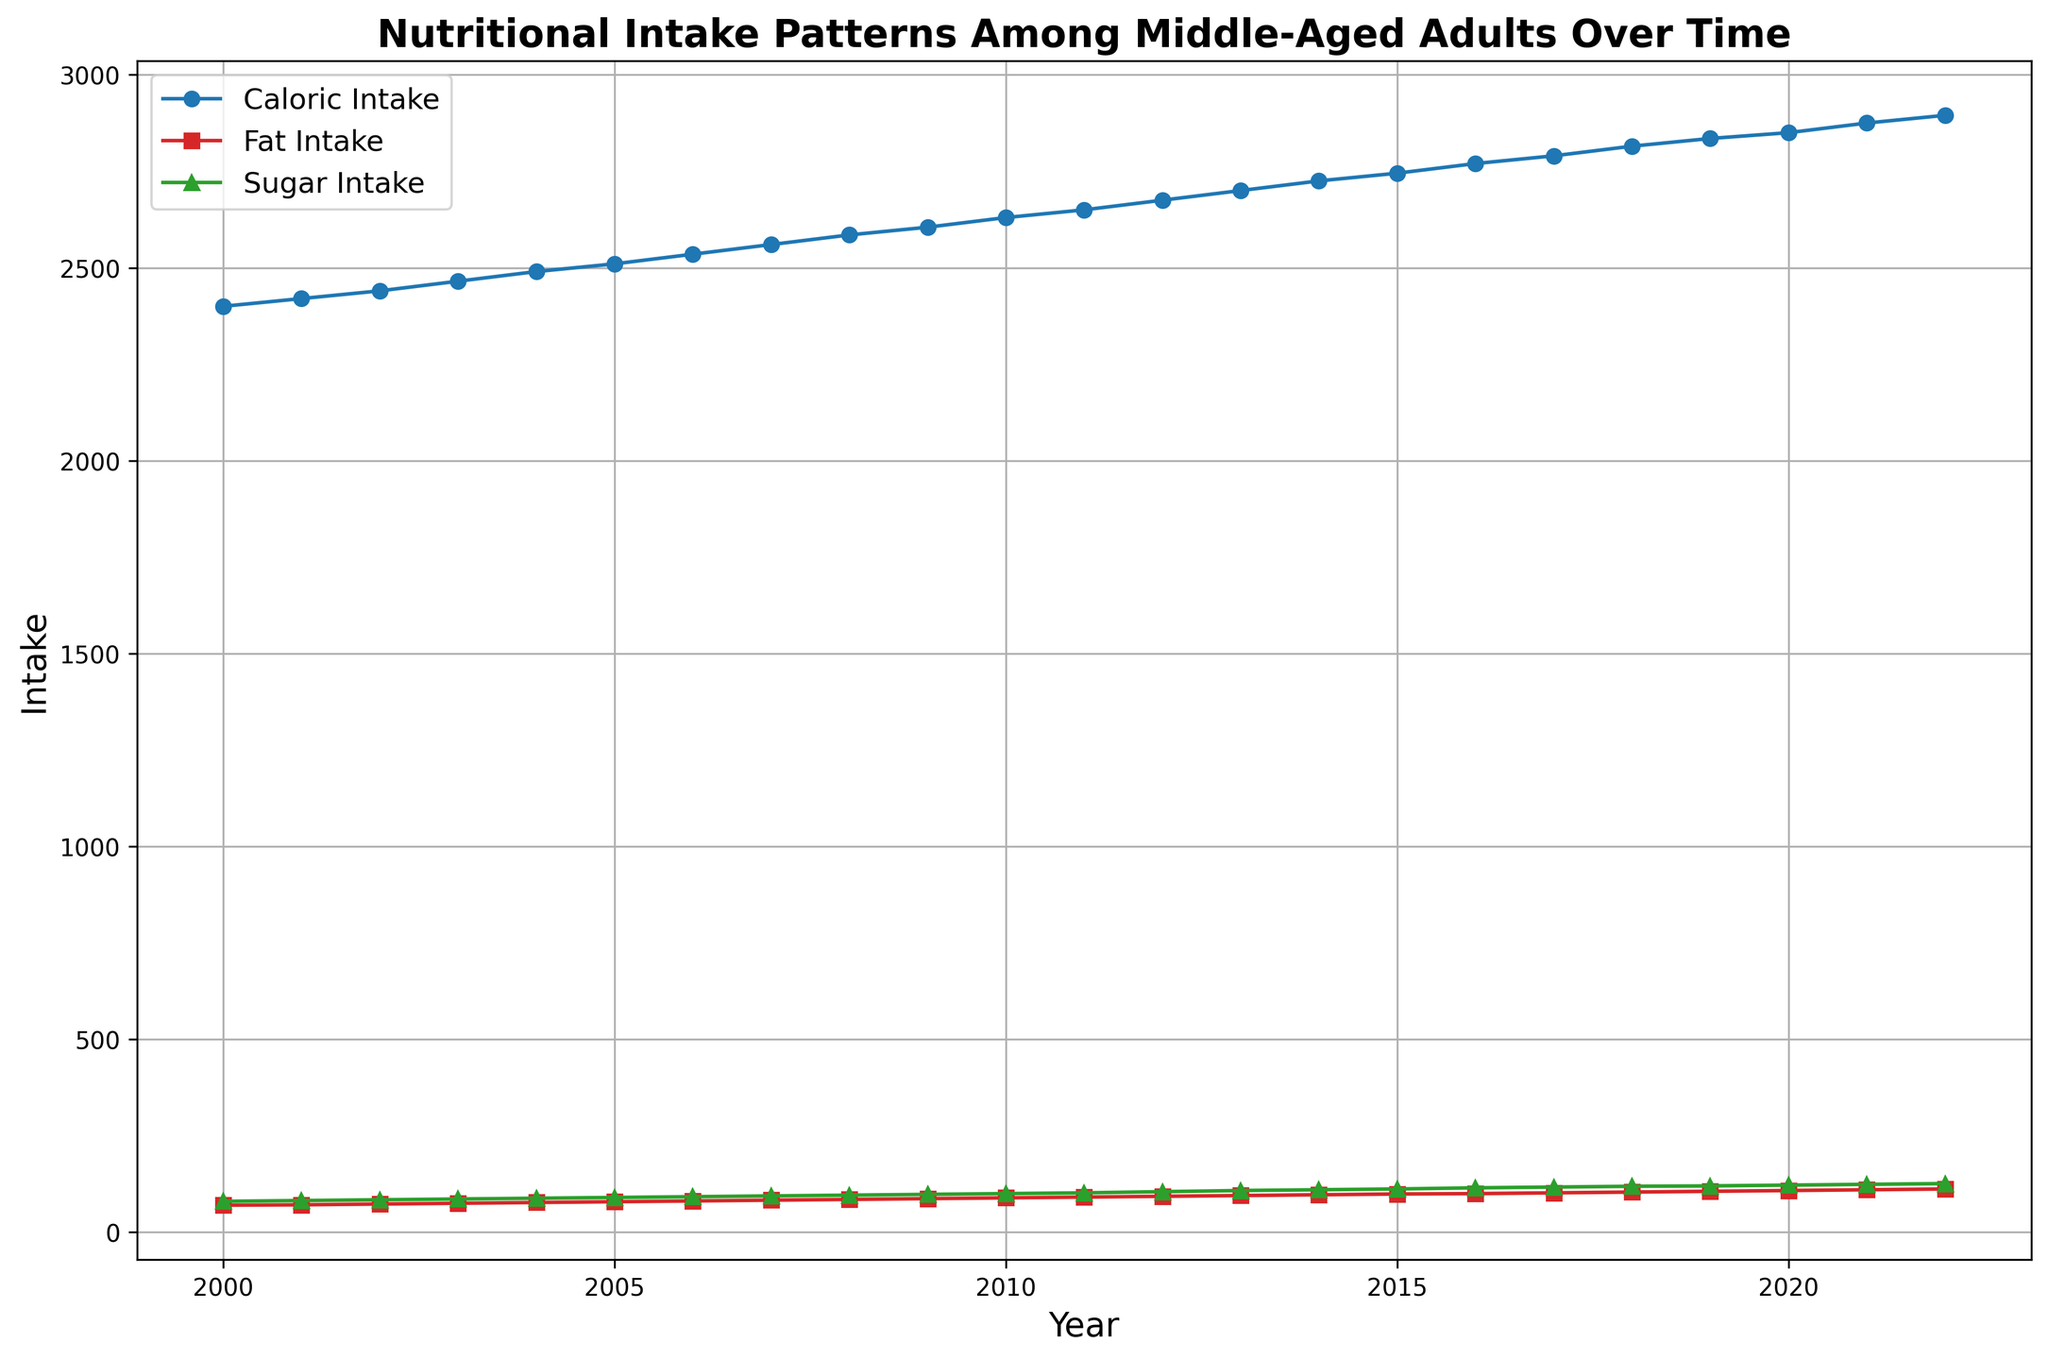What year had the highest average caloric intake? The highest point on the line for average caloric intake is at the year 2022, with a caloric intake of 2895 kcal.
Answer: 2022 Compare the average fat intake in 2005 with that in 2020. Which year had a higher intake? The plotted line shows that the average fat intake in 2005 was 79 grams, while in 2020 it was 108 grams. Therefore, 2020 had a higher fat intake.
Answer: 2020 What is the difference between the average sugar intake in the years 2000 and 2022? From the graph, the average sugar intake in 2000 was 80 grams, and in 2022 it was 126 grams. The difference is 126 - 80 = 46 grams.
Answer: 46 grams Which nutritional aspect showed the steepest increase from 2000 to 2022? Observing the slope of each line, the line representing average sugar intake has the steepest upward trend from 2000 (80 grams) to 2022 (126 grams), showing that sugar intake increased the most.
Answer: Sugar Intake What was the average fat intake in the year when average caloric intake was 2630 kcal? The plot shows that the average caloric intake was 2630 kcal in 2010. In that same year, the average fat intake was 89 grams.
Answer: 89 grams How much did the average caloric intake increase from 2010 to 2020? In 2010, the caloric intake was 2630 kcal, and in 2020 it was 2850 kcal. The increase is 2850 - 2630 = 220 kcal.
Answer: 220 kcal In which year did the average sugar intake reach 100 grams? The line for average sugar intake hits the 100-gram mark at the year 2010, as evident from the plotted data.
Answer: 2010 What was the combined average fat and sugar intake in 2015? In 2015, the average fat intake was 99 grams and the sugar intake was 112 grams. The combined intake is 99 + 112 = 211 grams.
Answer: 211 grams Between which consecutive years did the average fat intake increase the most? The largest increase in average fat intake happened between 2021 (110 grams) and 2022 (112 grams), which is an increase of 2 grams.
Answer: Between 2021 and 2022 At what rate did the average caloric intake change per year from 2000 to 2022? The average caloric intake increased from 2400 kcal in 2000 to 2895 kcal in 2022, over 22 years. The rate of change per year is (2895 - 2400) / 22 ≈ 22.5 kcal per year.
Answer: 22.5 kcal per year 